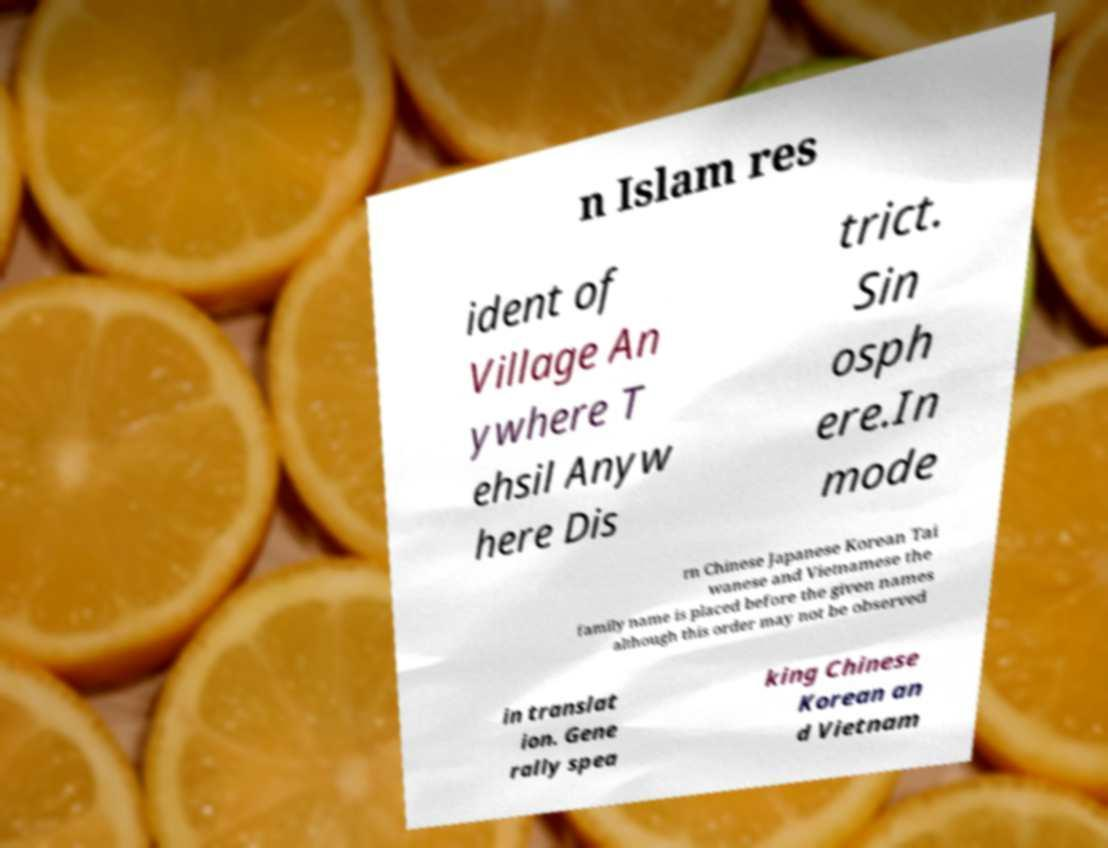Please identify and transcribe the text found in this image. n Islam res ident of Village An ywhere T ehsil Anyw here Dis trict. Sin osph ere.In mode rn Chinese Japanese Korean Tai wanese and Vietnamese the family name is placed before the given names although this order may not be observed in translat ion. Gene rally spea king Chinese Korean an d Vietnam 